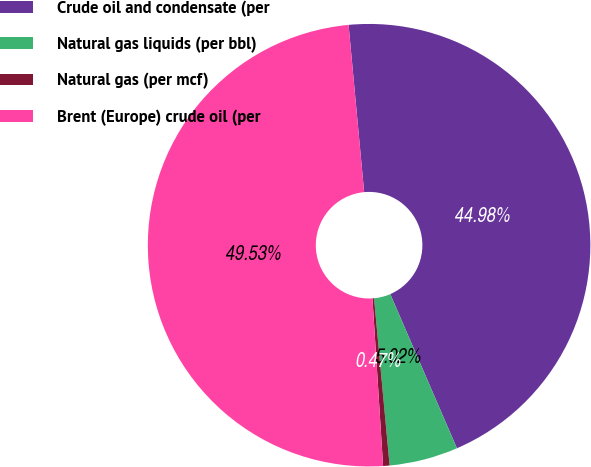Convert chart to OTSL. <chart><loc_0><loc_0><loc_500><loc_500><pie_chart><fcel>Crude oil and condensate (per<fcel>Natural gas liquids (per bbl)<fcel>Natural gas (per mcf)<fcel>Brent (Europe) crude oil (per<nl><fcel>44.98%<fcel>5.02%<fcel>0.47%<fcel>49.53%<nl></chart> 